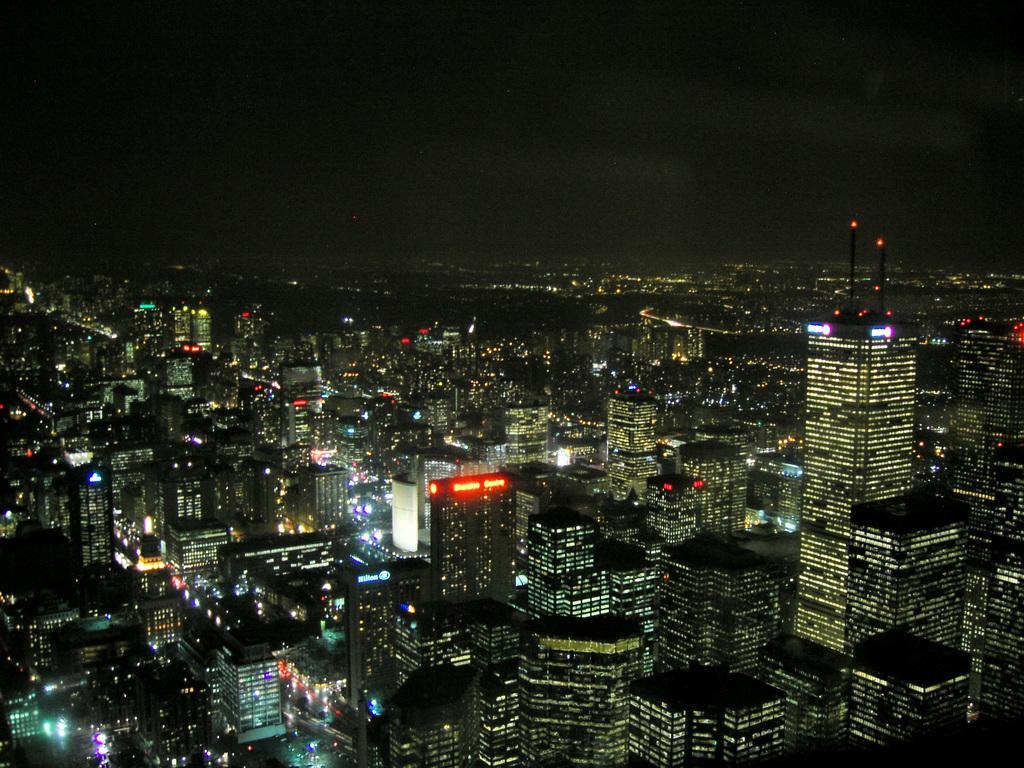Describe this image in one or two sentences. In this image I can see many buildings with lights. I can see the LED boards to few buildings. In the background I can see the sky. 